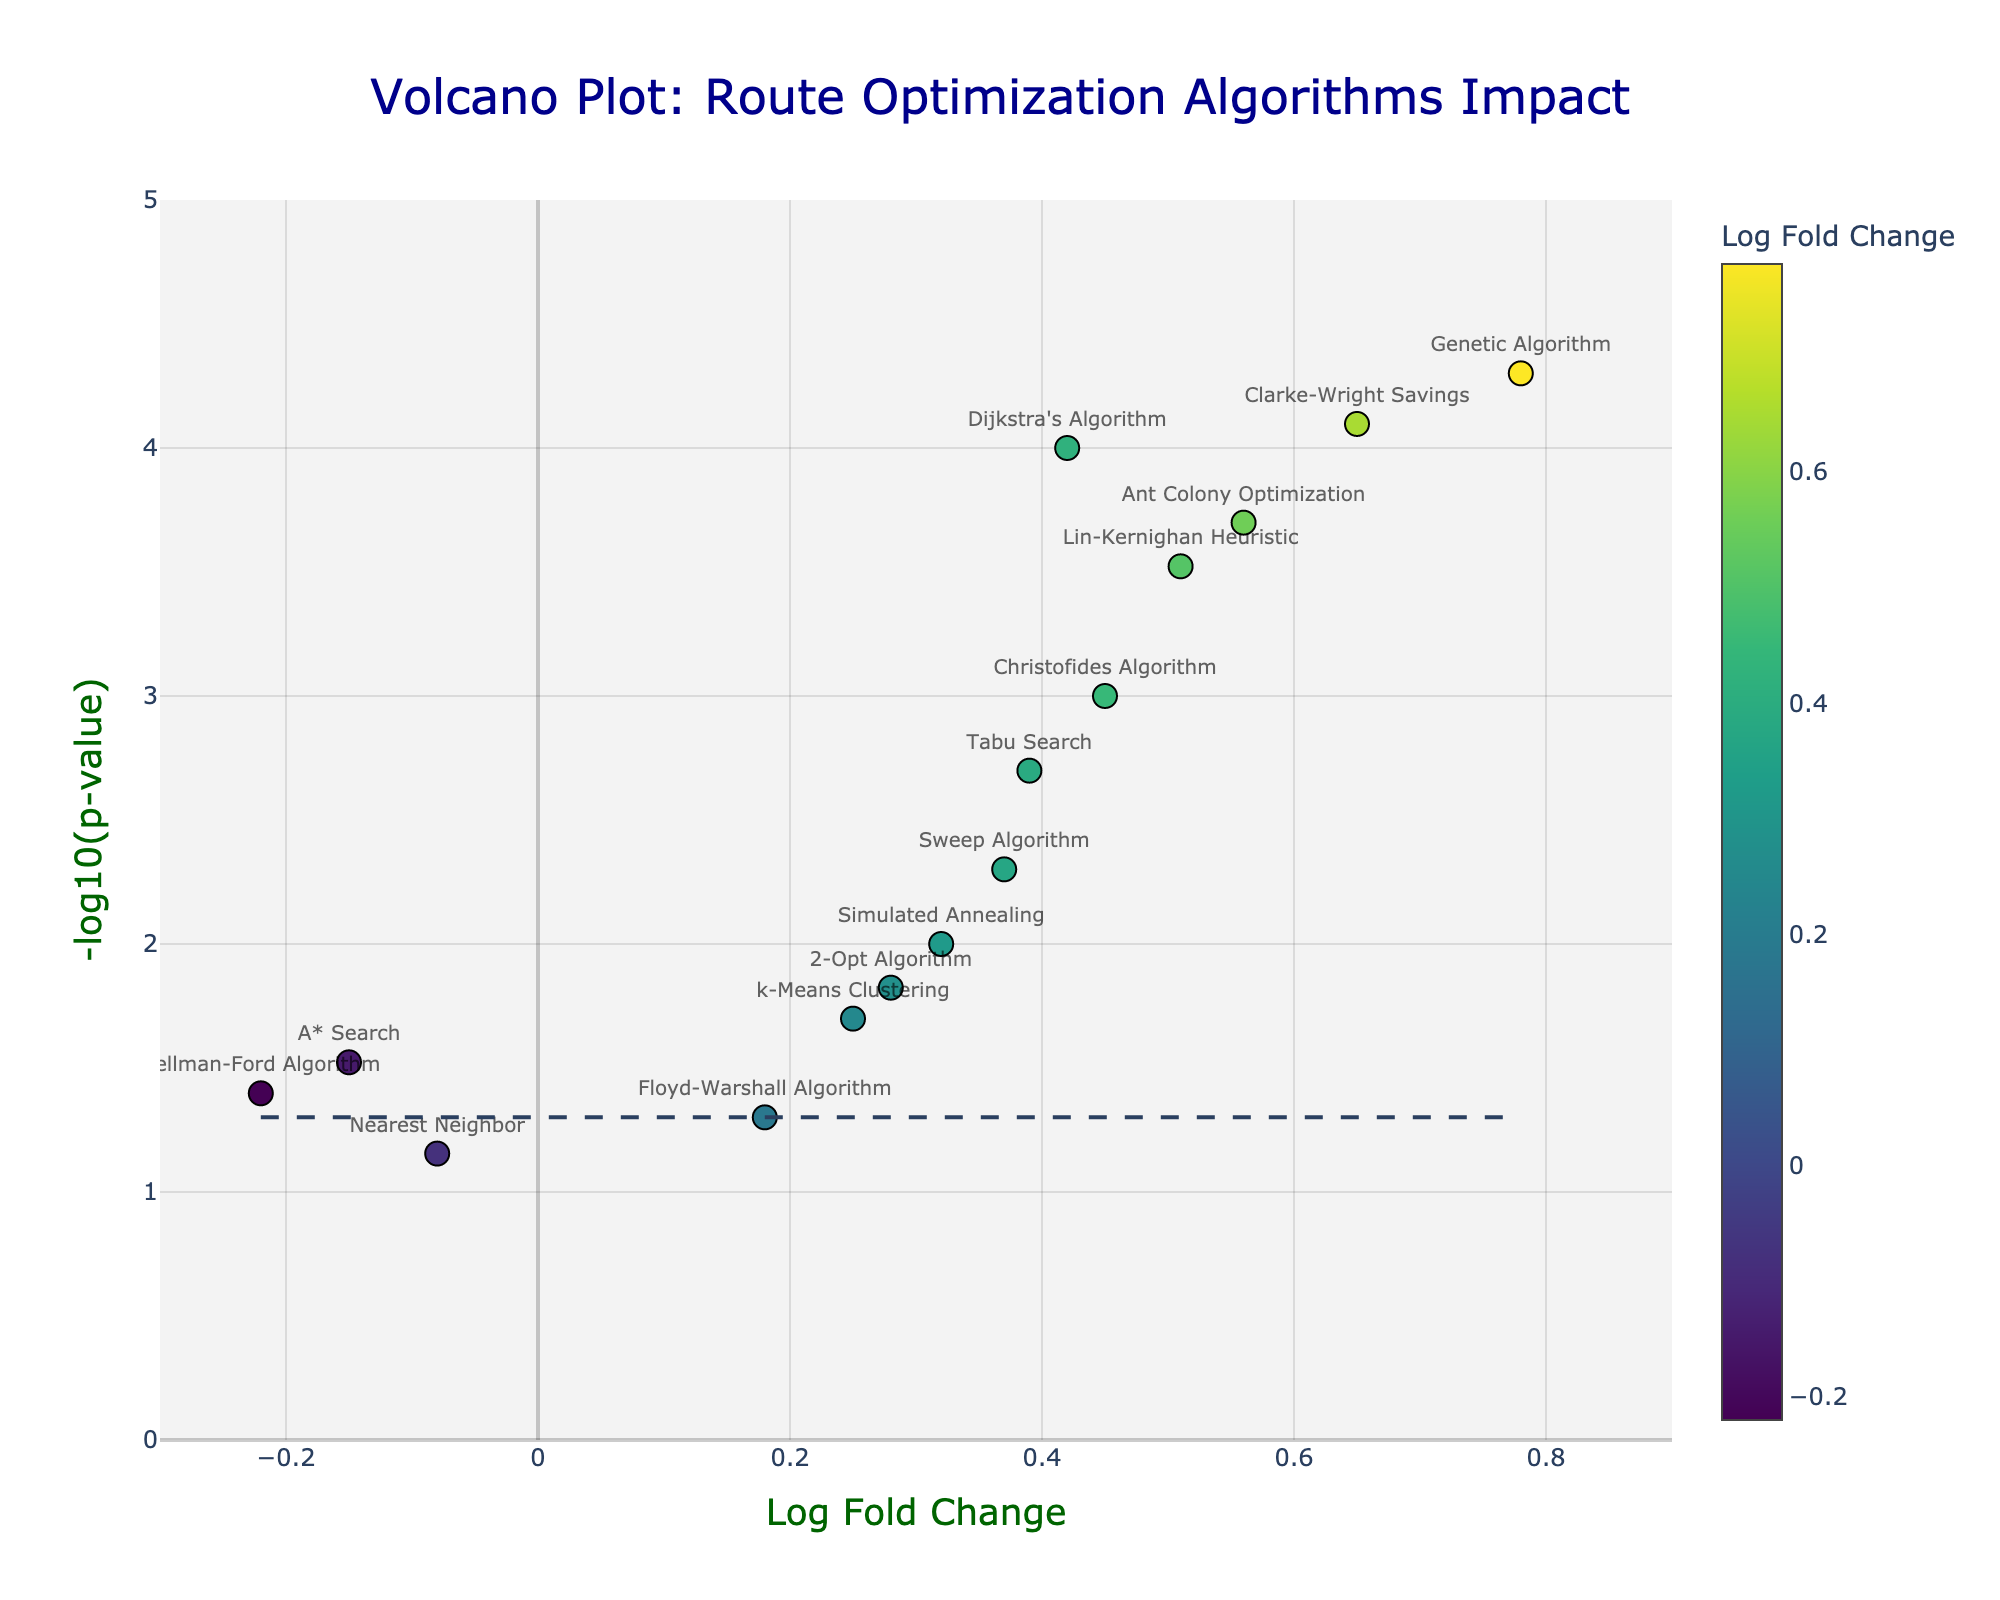what is the title of the plot? The title is located at the top of the plot and typically summarizes the main subject of the figure.
Answer: Volcano Plot: Route Optimization Algorithms Impact How many algorithms have a Log Fold Change greater than 0.5? To determine this, count the number of data points (algorithms) on the x-axis that have a value greater than 0.5.
Answer: 4 Which algorithm has the highest Log Fold Change? Locate the data point with the highest x-axis value (Log Fold Change) and identify the corresponding algorithm from the label.
Answer: Genetic Algorithm Is there any algorithm with a Log Fold Change less than -0.2? Look for data points on the left of the -0.2 mark on the x-axis and identify if there is any point.
Answer: Yes Which data point represents a statistically significant improvement? Statistically significant improvements are typically represented by data points above the significance threshold line on the y-axis.
Answer: Several, including Dijkstra's Algorithm, Genetic Algorithm, etc What is the Log Fold Change and p-value for the Ant Colony Optimization algorithm? Find the Ant Colony Optimization data point, hover over it or read the nearest label, then read the corresponding x and y values (Log Fold Change and p-value).
Answer: 0.56 and 0.0002 How does Simulated Annealing compare to A* Search in terms of Log Fold Change? Identify both data points on the x-axis, compare their positions to provide which one has a higher or lower Log Fold Change.
Answer: Simulated Annealing has a higher Log Fold Change than A* Search What color represents the highest Log Fold Change, and which algorithm does it correspond to? The color scale on the plot is used to represent Log Fold Change; the data point with the brightest or highest color corresponds to the highest Log Fold Change.
Answer: Bright yellow, Genetic Algorithm Which algorithms fall below the significance threshold line and have negative Log Fold Changes? Identify the data points below the horizontal significance threshold line and then check if they are on the left of the y-axis (negative Log Fold Change).
Answer: Bellman-Ford Algorithm What is the significance threshold for p-value in this plot? The significance threshold is represented by a horizontal dashed line, the y-value at this line indicates the -log10(p-value) cutoff for significance.
Answer: -log10(0.05) or approximately 1.3 